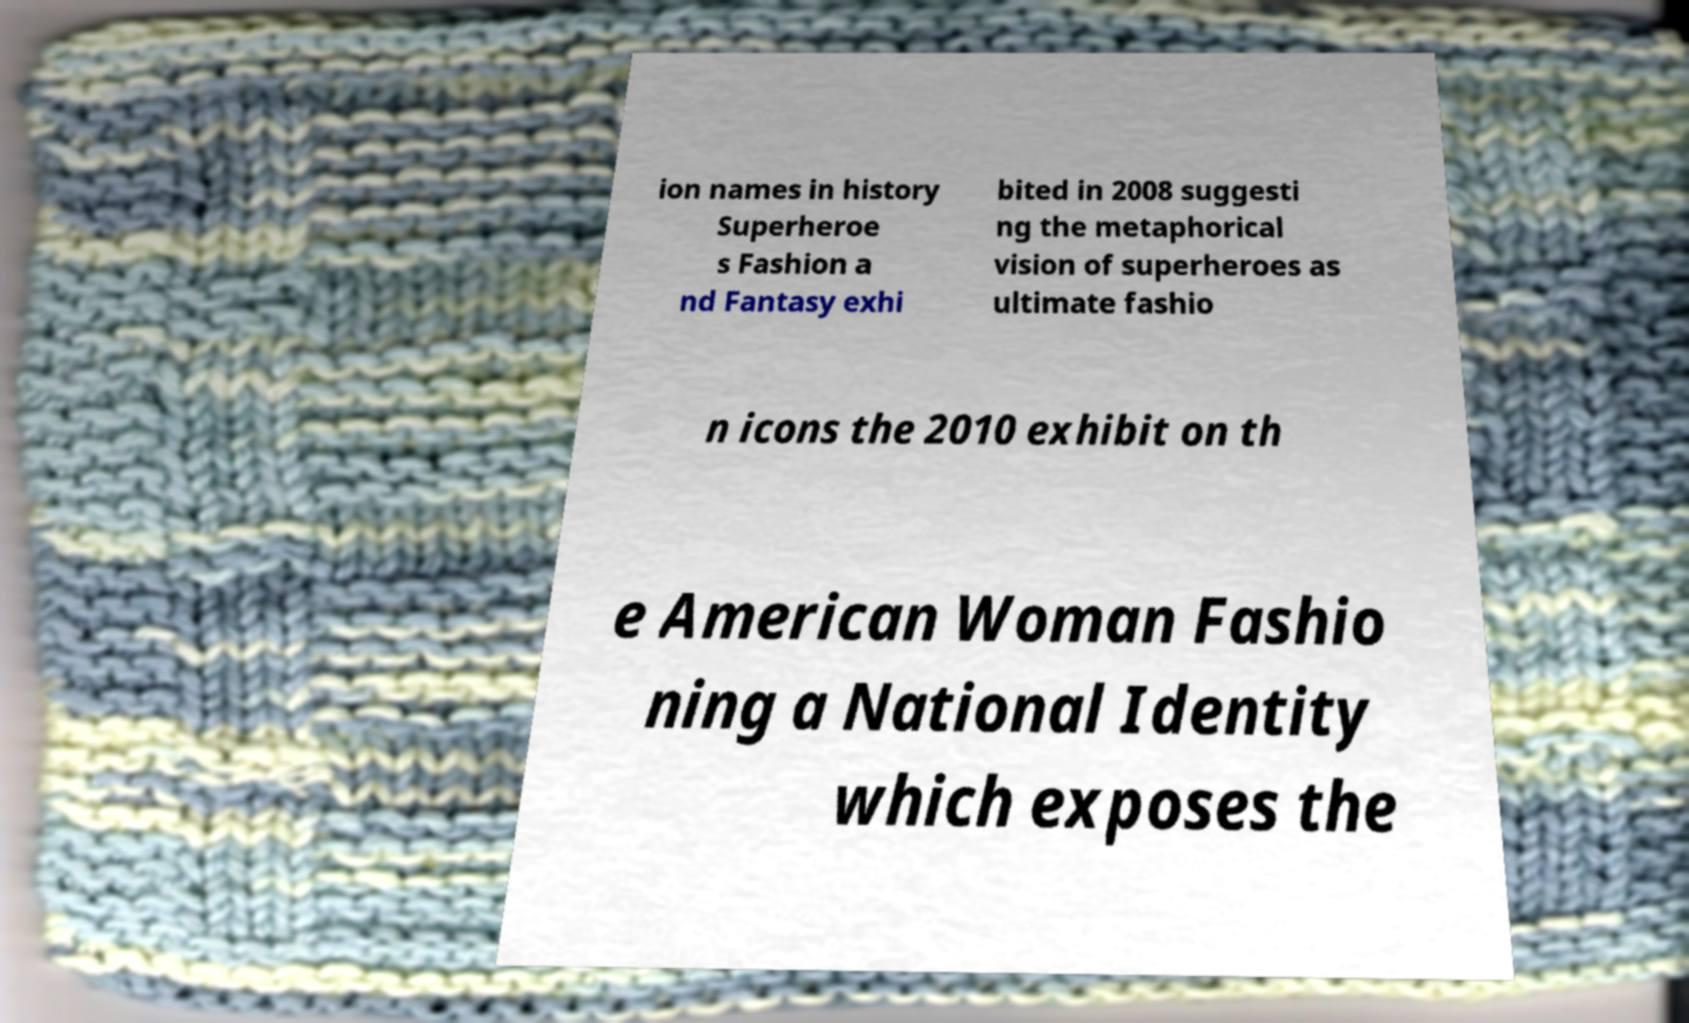Please read and relay the text visible in this image. What does it say? ion names in history Superheroe s Fashion a nd Fantasy exhi bited in 2008 suggesti ng the metaphorical vision of superheroes as ultimate fashio n icons the 2010 exhibit on th e American Woman Fashio ning a National Identity which exposes the 